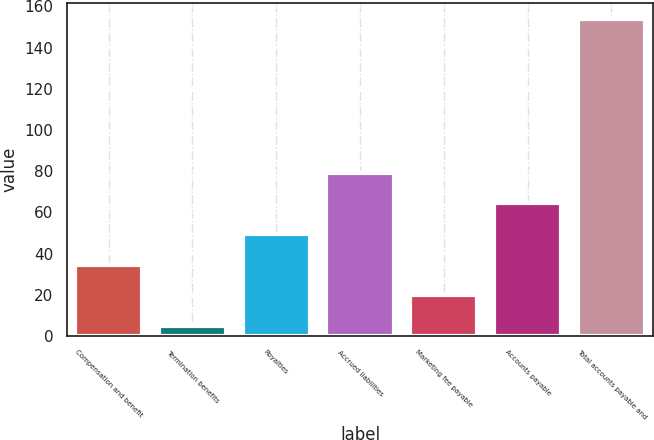Convert chart to OTSL. <chart><loc_0><loc_0><loc_500><loc_500><bar_chart><fcel>Compensation and benefit<fcel>Termination benefits<fcel>Royalties<fcel>Accrued liabilities<fcel>Marketing fee payable<fcel>Accounts payable<fcel>Total accounts payable and<nl><fcel>34.6<fcel>4.8<fcel>49.5<fcel>79.3<fcel>19.7<fcel>64.4<fcel>153.8<nl></chart> 